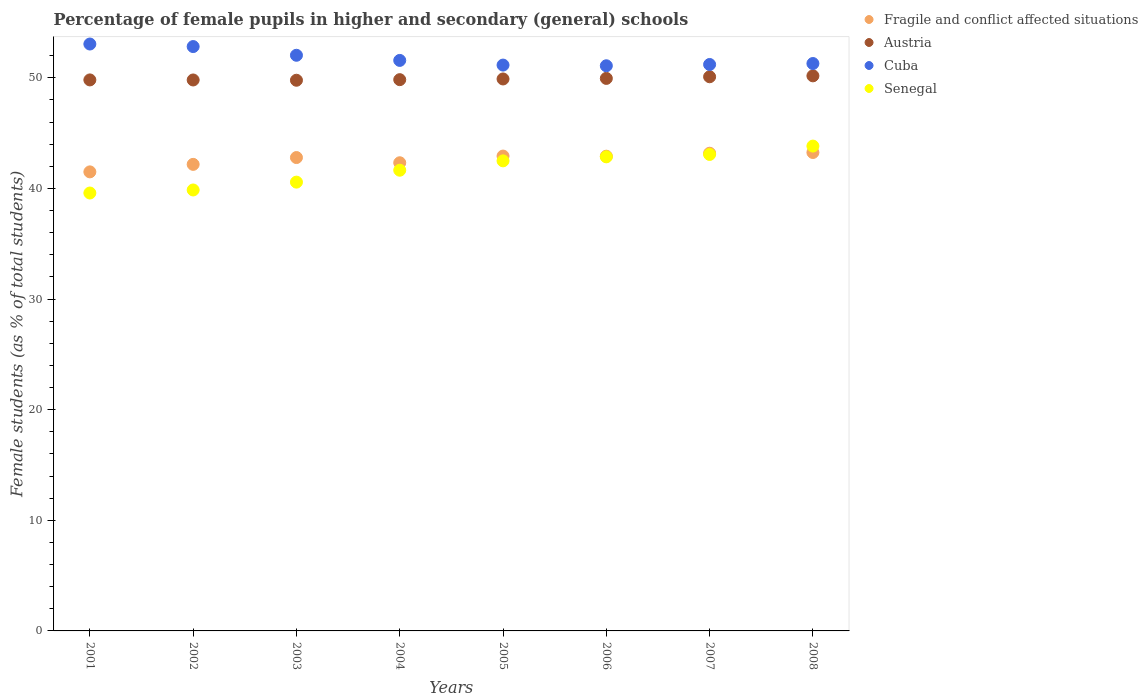How many different coloured dotlines are there?
Ensure brevity in your answer.  4. What is the percentage of female pupils in higher and secondary schools in Cuba in 2007?
Ensure brevity in your answer.  51.2. Across all years, what is the maximum percentage of female pupils in higher and secondary schools in Austria?
Offer a terse response. 50.17. Across all years, what is the minimum percentage of female pupils in higher and secondary schools in Cuba?
Make the answer very short. 51.08. In which year was the percentage of female pupils in higher and secondary schools in Cuba maximum?
Offer a terse response. 2001. What is the total percentage of female pupils in higher and secondary schools in Cuba in the graph?
Make the answer very short. 414.18. What is the difference between the percentage of female pupils in higher and secondary schools in Fragile and conflict affected situations in 2001 and that in 2008?
Your answer should be very brief. -1.75. What is the difference between the percentage of female pupils in higher and secondary schools in Austria in 2002 and the percentage of female pupils in higher and secondary schools in Fragile and conflict affected situations in 2005?
Keep it short and to the point. 6.88. What is the average percentage of female pupils in higher and secondary schools in Austria per year?
Make the answer very short. 49.91. In the year 2004, what is the difference between the percentage of female pupils in higher and secondary schools in Fragile and conflict affected situations and percentage of female pupils in higher and secondary schools in Senegal?
Give a very brief answer. 0.67. What is the ratio of the percentage of female pupils in higher and secondary schools in Cuba in 2002 to that in 2005?
Make the answer very short. 1.03. Is the percentage of female pupils in higher and secondary schools in Austria in 2002 less than that in 2007?
Keep it short and to the point. Yes. What is the difference between the highest and the second highest percentage of female pupils in higher and secondary schools in Fragile and conflict affected situations?
Make the answer very short. 0.07. What is the difference between the highest and the lowest percentage of female pupils in higher and secondary schools in Cuba?
Ensure brevity in your answer.  1.97. Is it the case that in every year, the sum of the percentage of female pupils in higher and secondary schools in Cuba and percentage of female pupils in higher and secondary schools in Fragile and conflict affected situations  is greater than the sum of percentage of female pupils in higher and secondary schools in Senegal and percentage of female pupils in higher and secondary schools in Austria?
Offer a terse response. Yes. Is it the case that in every year, the sum of the percentage of female pupils in higher and secondary schools in Austria and percentage of female pupils in higher and secondary schools in Cuba  is greater than the percentage of female pupils in higher and secondary schools in Fragile and conflict affected situations?
Your answer should be compact. Yes. Does the percentage of female pupils in higher and secondary schools in Austria monotonically increase over the years?
Your answer should be compact. No. Is the percentage of female pupils in higher and secondary schools in Cuba strictly greater than the percentage of female pupils in higher and secondary schools in Austria over the years?
Offer a very short reply. Yes. Is the percentage of female pupils in higher and secondary schools in Fragile and conflict affected situations strictly less than the percentage of female pupils in higher and secondary schools in Senegal over the years?
Offer a very short reply. No. Are the values on the major ticks of Y-axis written in scientific E-notation?
Make the answer very short. No. Does the graph contain any zero values?
Give a very brief answer. No. Does the graph contain grids?
Ensure brevity in your answer.  No. How many legend labels are there?
Keep it short and to the point. 4. What is the title of the graph?
Keep it short and to the point. Percentage of female pupils in higher and secondary (general) schools. Does "Canada" appear as one of the legend labels in the graph?
Your answer should be very brief. No. What is the label or title of the Y-axis?
Provide a succinct answer. Female students (as % of total students). What is the Female students (as % of total students) in Fragile and conflict affected situations in 2001?
Give a very brief answer. 41.49. What is the Female students (as % of total students) of Austria in 2001?
Offer a very short reply. 49.8. What is the Female students (as % of total students) of Cuba in 2001?
Keep it short and to the point. 53.05. What is the Female students (as % of total students) of Senegal in 2001?
Your answer should be compact. 39.58. What is the Female students (as % of total students) of Fragile and conflict affected situations in 2002?
Make the answer very short. 42.17. What is the Female students (as % of total students) of Austria in 2002?
Ensure brevity in your answer.  49.8. What is the Female students (as % of total students) of Cuba in 2002?
Your response must be concise. 52.82. What is the Female students (as % of total students) in Senegal in 2002?
Give a very brief answer. 39.86. What is the Female students (as % of total students) of Fragile and conflict affected situations in 2003?
Offer a very short reply. 42.79. What is the Female students (as % of total students) in Austria in 2003?
Your answer should be very brief. 49.77. What is the Female students (as % of total students) in Cuba in 2003?
Give a very brief answer. 52.03. What is the Female students (as % of total students) of Senegal in 2003?
Offer a very short reply. 40.57. What is the Female students (as % of total students) in Fragile and conflict affected situations in 2004?
Offer a very short reply. 42.32. What is the Female students (as % of total students) in Austria in 2004?
Offer a terse response. 49.83. What is the Female students (as % of total students) in Cuba in 2004?
Your response must be concise. 51.57. What is the Female students (as % of total students) in Senegal in 2004?
Your answer should be very brief. 41.64. What is the Female students (as % of total students) in Fragile and conflict affected situations in 2005?
Offer a terse response. 42.92. What is the Female students (as % of total students) of Austria in 2005?
Offer a terse response. 49.89. What is the Female students (as % of total students) in Cuba in 2005?
Provide a succinct answer. 51.14. What is the Female students (as % of total students) in Senegal in 2005?
Your answer should be very brief. 42.49. What is the Female students (as % of total students) in Fragile and conflict affected situations in 2006?
Make the answer very short. 42.91. What is the Female students (as % of total students) in Austria in 2006?
Provide a succinct answer. 49.94. What is the Female students (as % of total students) of Cuba in 2006?
Offer a terse response. 51.08. What is the Female students (as % of total students) of Senegal in 2006?
Provide a short and direct response. 42.85. What is the Female students (as % of total students) of Fragile and conflict affected situations in 2007?
Your response must be concise. 43.18. What is the Female students (as % of total students) of Austria in 2007?
Your response must be concise. 50.09. What is the Female students (as % of total students) of Cuba in 2007?
Offer a very short reply. 51.2. What is the Female students (as % of total students) of Senegal in 2007?
Provide a succinct answer. 43.07. What is the Female students (as % of total students) in Fragile and conflict affected situations in 2008?
Offer a very short reply. 43.24. What is the Female students (as % of total students) in Austria in 2008?
Your answer should be compact. 50.17. What is the Female students (as % of total students) of Cuba in 2008?
Provide a succinct answer. 51.29. What is the Female students (as % of total students) in Senegal in 2008?
Give a very brief answer. 43.82. Across all years, what is the maximum Female students (as % of total students) in Fragile and conflict affected situations?
Your response must be concise. 43.24. Across all years, what is the maximum Female students (as % of total students) of Austria?
Your response must be concise. 50.17. Across all years, what is the maximum Female students (as % of total students) of Cuba?
Your answer should be compact. 53.05. Across all years, what is the maximum Female students (as % of total students) in Senegal?
Your answer should be very brief. 43.82. Across all years, what is the minimum Female students (as % of total students) in Fragile and conflict affected situations?
Your answer should be very brief. 41.49. Across all years, what is the minimum Female students (as % of total students) of Austria?
Provide a short and direct response. 49.77. Across all years, what is the minimum Female students (as % of total students) of Cuba?
Make the answer very short. 51.08. Across all years, what is the minimum Female students (as % of total students) in Senegal?
Provide a short and direct response. 39.58. What is the total Female students (as % of total students) in Fragile and conflict affected situations in the graph?
Make the answer very short. 341.02. What is the total Female students (as % of total students) in Austria in the graph?
Provide a short and direct response. 399.3. What is the total Female students (as % of total students) in Cuba in the graph?
Provide a succinct answer. 414.18. What is the total Female students (as % of total students) of Senegal in the graph?
Your response must be concise. 333.88. What is the difference between the Female students (as % of total students) in Fragile and conflict affected situations in 2001 and that in 2002?
Provide a succinct answer. -0.68. What is the difference between the Female students (as % of total students) of Austria in 2001 and that in 2002?
Offer a terse response. 0.01. What is the difference between the Female students (as % of total students) of Cuba in 2001 and that in 2002?
Provide a short and direct response. 0.23. What is the difference between the Female students (as % of total students) in Senegal in 2001 and that in 2002?
Ensure brevity in your answer.  -0.28. What is the difference between the Female students (as % of total students) of Fragile and conflict affected situations in 2001 and that in 2003?
Ensure brevity in your answer.  -1.29. What is the difference between the Female students (as % of total students) of Cuba in 2001 and that in 2003?
Offer a terse response. 1.02. What is the difference between the Female students (as % of total students) in Senegal in 2001 and that in 2003?
Your answer should be compact. -0.98. What is the difference between the Female students (as % of total students) of Fragile and conflict affected situations in 2001 and that in 2004?
Offer a very short reply. -0.82. What is the difference between the Female students (as % of total students) in Austria in 2001 and that in 2004?
Give a very brief answer. -0.02. What is the difference between the Female students (as % of total students) of Cuba in 2001 and that in 2004?
Make the answer very short. 1.48. What is the difference between the Female students (as % of total students) of Senegal in 2001 and that in 2004?
Your answer should be very brief. -2.06. What is the difference between the Female students (as % of total students) in Fragile and conflict affected situations in 2001 and that in 2005?
Provide a succinct answer. -1.43. What is the difference between the Female students (as % of total students) in Austria in 2001 and that in 2005?
Give a very brief answer. -0.09. What is the difference between the Female students (as % of total students) of Cuba in 2001 and that in 2005?
Your answer should be compact. 1.9. What is the difference between the Female students (as % of total students) in Senegal in 2001 and that in 2005?
Your answer should be compact. -2.91. What is the difference between the Female students (as % of total students) of Fragile and conflict affected situations in 2001 and that in 2006?
Your answer should be compact. -1.42. What is the difference between the Female students (as % of total students) in Austria in 2001 and that in 2006?
Your answer should be compact. -0.14. What is the difference between the Female students (as % of total students) in Cuba in 2001 and that in 2006?
Offer a very short reply. 1.97. What is the difference between the Female students (as % of total students) in Senegal in 2001 and that in 2006?
Ensure brevity in your answer.  -3.27. What is the difference between the Female students (as % of total students) in Fragile and conflict affected situations in 2001 and that in 2007?
Offer a terse response. -1.69. What is the difference between the Female students (as % of total students) of Austria in 2001 and that in 2007?
Offer a very short reply. -0.28. What is the difference between the Female students (as % of total students) in Cuba in 2001 and that in 2007?
Your answer should be very brief. 1.85. What is the difference between the Female students (as % of total students) in Senegal in 2001 and that in 2007?
Make the answer very short. -3.49. What is the difference between the Female students (as % of total students) of Fragile and conflict affected situations in 2001 and that in 2008?
Offer a very short reply. -1.75. What is the difference between the Female students (as % of total students) of Austria in 2001 and that in 2008?
Keep it short and to the point. -0.37. What is the difference between the Female students (as % of total students) in Cuba in 2001 and that in 2008?
Make the answer very short. 1.76. What is the difference between the Female students (as % of total students) in Senegal in 2001 and that in 2008?
Your response must be concise. -4.24. What is the difference between the Female students (as % of total students) of Fragile and conflict affected situations in 2002 and that in 2003?
Give a very brief answer. -0.62. What is the difference between the Female students (as % of total students) in Austria in 2002 and that in 2003?
Offer a very short reply. 0.03. What is the difference between the Female students (as % of total students) of Cuba in 2002 and that in 2003?
Offer a terse response. 0.79. What is the difference between the Female students (as % of total students) of Senegal in 2002 and that in 2003?
Keep it short and to the point. -0.71. What is the difference between the Female students (as % of total students) in Fragile and conflict affected situations in 2002 and that in 2004?
Provide a succinct answer. -0.15. What is the difference between the Female students (as % of total students) of Austria in 2002 and that in 2004?
Offer a very short reply. -0.03. What is the difference between the Female students (as % of total students) in Cuba in 2002 and that in 2004?
Provide a succinct answer. 1.25. What is the difference between the Female students (as % of total students) of Senegal in 2002 and that in 2004?
Ensure brevity in your answer.  -1.79. What is the difference between the Female students (as % of total students) in Fragile and conflict affected situations in 2002 and that in 2005?
Ensure brevity in your answer.  -0.75. What is the difference between the Female students (as % of total students) of Austria in 2002 and that in 2005?
Give a very brief answer. -0.09. What is the difference between the Female students (as % of total students) of Cuba in 2002 and that in 2005?
Keep it short and to the point. 1.67. What is the difference between the Female students (as % of total students) of Senegal in 2002 and that in 2005?
Your answer should be very brief. -2.63. What is the difference between the Female students (as % of total students) in Fragile and conflict affected situations in 2002 and that in 2006?
Offer a very short reply. -0.74. What is the difference between the Female students (as % of total students) of Austria in 2002 and that in 2006?
Provide a succinct answer. -0.14. What is the difference between the Female students (as % of total students) of Cuba in 2002 and that in 2006?
Offer a terse response. 1.74. What is the difference between the Female students (as % of total students) in Senegal in 2002 and that in 2006?
Keep it short and to the point. -2.99. What is the difference between the Female students (as % of total students) in Fragile and conflict affected situations in 2002 and that in 2007?
Offer a very short reply. -1.01. What is the difference between the Female students (as % of total students) in Austria in 2002 and that in 2007?
Offer a terse response. -0.29. What is the difference between the Female students (as % of total students) in Cuba in 2002 and that in 2007?
Provide a short and direct response. 1.62. What is the difference between the Female students (as % of total students) of Senegal in 2002 and that in 2007?
Your answer should be very brief. -3.21. What is the difference between the Female students (as % of total students) in Fragile and conflict affected situations in 2002 and that in 2008?
Ensure brevity in your answer.  -1.07. What is the difference between the Female students (as % of total students) in Austria in 2002 and that in 2008?
Give a very brief answer. -0.37. What is the difference between the Female students (as % of total students) of Cuba in 2002 and that in 2008?
Your answer should be very brief. 1.53. What is the difference between the Female students (as % of total students) in Senegal in 2002 and that in 2008?
Your answer should be compact. -3.97. What is the difference between the Female students (as % of total students) in Fragile and conflict affected situations in 2003 and that in 2004?
Your answer should be very brief. 0.47. What is the difference between the Female students (as % of total students) of Austria in 2003 and that in 2004?
Ensure brevity in your answer.  -0.05. What is the difference between the Female students (as % of total students) in Cuba in 2003 and that in 2004?
Ensure brevity in your answer.  0.46. What is the difference between the Female students (as % of total students) of Senegal in 2003 and that in 2004?
Provide a short and direct response. -1.08. What is the difference between the Female students (as % of total students) in Fragile and conflict affected situations in 2003 and that in 2005?
Offer a terse response. -0.13. What is the difference between the Female students (as % of total students) in Austria in 2003 and that in 2005?
Offer a very short reply. -0.12. What is the difference between the Female students (as % of total students) in Cuba in 2003 and that in 2005?
Keep it short and to the point. 0.89. What is the difference between the Female students (as % of total students) in Senegal in 2003 and that in 2005?
Provide a succinct answer. -1.92. What is the difference between the Female students (as % of total students) of Fragile and conflict affected situations in 2003 and that in 2006?
Keep it short and to the point. -0.12. What is the difference between the Female students (as % of total students) in Cuba in 2003 and that in 2006?
Ensure brevity in your answer.  0.95. What is the difference between the Female students (as % of total students) in Senegal in 2003 and that in 2006?
Provide a succinct answer. -2.29. What is the difference between the Female students (as % of total students) in Fragile and conflict affected situations in 2003 and that in 2007?
Your response must be concise. -0.39. What is the difference between the Female students (as % of total students) in Austria in 2003 and that in 2007?
Make the answer very short. -0.31. What is the difference between the Female students (as % of total students) of Cuba in 2003 and that in 2007?
Ensure brevity in your answer.  0.83. What is the difference between the Female students (as % of total students) in Senegal in 2003 and that in 2007?
Offer a terse response. -2.5. What is the difference between the Female students (as % of total students) in Fragile and conflict affected situations in 2003 and that in 2008?
Provide a short and direct response. -0.46. What is the difference between the Female students (as % of total students) in Austria in 2003 and that in 2008?
Provide a short and direct response. -0.4. What is the difference between the Female students (as % of total students) in Cuba in 2003 and that in 2008?
Your response must be concise. 0.75. What is the difference between the Female students (as % of total students) in Senegal in 2003 and that in 2008?
Your response must be concise. -3.26. What is the difference between the Female students (as % of total students) in Fragile and conflict affected situations in 2004 and that in 2005?
Give a very brief answer. -0.6. What is the difference between the Female students (as % of total students) in Austria in 2004 and that in 2005?
Your response must be concise. -0.06. What is the difference between the Female students (as % of total students) in Cuba in 2004 and that in 2005?
Your answer should be compact. 0.42. What is the difference between the Female students (as % of total students) in Senegal in 2004 and that in 2005?
Your response must be concise. -0.85. What is the difference between the Female students (as % of total students) of Fragile and conflict affected situations in 2004 and that in 2006?
Provide a short and direct response. -0.59. What is the difference between the Female students (as % of total students) in Austria in 2004 and that in 2006?
Keep it short and to the point. -0.11. What is the difference between the Female students (as % of total students) of Cuba in 2004 and that in 2006?
Provide a succinct answer. 0.48. What is the difference between the Female students (as % of total students) of Senegal in 2004 and that in 2006?
Keep it short and to the point. -1.21. What is the difference between the Female students (as % of total students) of Fragile and conflict affected situations in 2004 and that in 2007?
Make the answer very short. -0.86. What is the difference between the Female students (as % of total students) of Austria in 2004 and that in 2007?
Offer a very short reply. -0.26. What is the difference between the Female students (as % of total students) in Cuba in 2004 and that in 2007?
Your answer should be very brief. 0.37. What is the difference between the Female students (as % of total students) in Senegal in 2004 and that in 2007?
Your response must be concise. -1.42. What is the difference between the Female students (as % of total students) of Fragile and conflict affected situations in 2004 and that in 2008?
Provide a short and direct response. -0.93. What is the difference between the Female students (as % of total students) of Austria in 2004 and that in 2008?
Keep it short and to the point. -0.34. What is the difference between the Female students (as % of total students) of Cuba in 2004 and that in 2008?
Your answer should be very brief. 0.28. What is the difference between the Female students (as % of total students) in Senegal in 2004 and that in 2008?
Your response must be concise. -2.18. What is the difference between the Female students (as % of total students) in Fragile and conflict affected situations in 2005 and that in 2006?
Your answer should be very brief. 0.01. What is the difference between the Female students (as % of total students) in Austria in 2005 and that in 2006?
Give a very brief answer. -0.05. What is the difference between the Female students (as % of total students) in Cuba in 2005 and that in 2006?
Give a very brief answer. 0.06. What is the difference between the Female students (as % of total students) of Senegal in 2005 and that in 2006?
Ensure brevity in your answer.  -0.36. What is the difference between the Female students (as % of total students) in Fragile and conflict affected situations in 2005 and that in 2007?
Give a very brief answer. -0.26. What is the difference between the Female students (as % of total students) in Austria in 2005 and that in 2007?
Provide a short and direct response. -0.2. What is the difference between the Female students (as % of total students) of Cuba in 2005 and that in 2007?
Your answer should be compact. -0.05. What is the difference between the Female students (as % of total students) in Senegal in 2005 and that in 2007?
Provide a short and direct response. -0.58. What is the difference between the Female students (as % of total students) in Fragile and conflict affected situations in 2005 and that in 2008?
Offer a very short reply. -0.32. What is the difference between the Female students (as % of total students) of Austria in 2005 and that in 2008?
Give a very brief answer. -0.28. What is the difference between the Female students (as % of total students) in Cuba in 2005 and that in 2008?
Keep it short and to the point. -0.14. What is the difference between the Female students (as % of total students) in Senegal in 2005 and that in 2008?
Keep it short and to the point. -1.34. What is the difference between the Female students (as % of total students) of Fragile and conflict affected situations in 2006 and that in 2007?
Ensure brevity in your answer.  -0.27. What is the difference between the Female students (as % of total students) in Austria in 2006 and that in 2007?
Ensure brevity in your answer.  -0.15. What is the difference between the Female students (as % of total students) in Cuba in 2006 and that in 2007?
Make the answer very short. -0.12. What is the difference between the Female students (as % of total students) in Senegal in 2006 and that in 2007?
Your answer should be compact. -0.22. What is the difference between the Female students (as % of total students) in Fragile and conflict affected situations in 2006 and that in 2008?
Provide a short and direct response. -0.33. What is the difference between the Female students (as % of total students) of Austria in 2006 and that in 2008?
Make the answer very short. -0.23. What is the difference between the Female students (as % of total students) of Cuba in 2006 and that in 2008?
Ensure brevity in your answer.  -0.2. What is the difference between the Female students (as % of total students) of Senegal in 2006 and that in 2008?
Provide a succinct answer. -0.97. What is the difference between the Female students (as % of total students) in Fragile and conflict affected situations in 2007 and that in 2008?
Keep it short and to the point. -0.07. What is the difference between the Female students (as % of total students) of Austria in 2007 and that in 2008?
Keep it short and to the point. -0.08. What is the difference between the Female students (as % of total students) in Cuba in 2007 and that in 2008?
Offer a terse response. -0.09. What is the difference between the Female students (as % of total students) in Senegal in 2007 and that in 2008?
Your answer should be compact. -0.76. What is the difference between the Female students (as % of total students) in Fragile and conflict affected situations in 2001 and the Female students (as % of total students) in Austria in 2002?
Give a very brief answer. -8.31. What is the difference between the Female students (as % of total students) of Fragile and conflict affected situations in 2001 and the Female students (as % of total students) of Cuba in 2002?
Your answer should be very brief. -11.33. What is the difference between the Female students (as % of total students) of Fragile and conflict affected situations in 2001 and the Female students (as % of total students) of Senegal in 2002?
Provide a succinct answer. 1.64. What is the difference between the Female students (as % of total students) in Austria in 2001 and the Female students (as % of total students) in Cuba in 2002?
Your answer should be compact. -3.01. What is the difference between the Female students (as % of total students) in Austria in 2001 and the Female students (as % of total students) in Senegal in 2002?
Your response must be concise. 9.95. What is the difference between the Female students (as % of total students) of Cuba in 2001 and the Female students (as % of total students) of Senegal in 2002?
Give a very brief answer. 13.19. What is the difference between the Female students (as % of total students) in Fragile and conflict affected situations in 2001 and the Female students (as % of total students) in Austria in 2003?
Your response must be concise. -8.28. What is the difference between the Female students (as % of total students) of Fragile and conflict affected situations in 2001 and the Female students (as % of total students) of Cuba in 2003?
Keep it short and to the point. -10.54. What is the difference between the Female students (as % of total students) in Fragile and conflict affected situations in 2001 and the Female students (as % of total students) in Senegal in 2003?
Keep it short and to the point. 0.93. What is the difference between the Female students (as % of total students) in Austria in 2001 and the Female students (as % of total students) in Cuba in 2003?
Make the answer very short. -2.23. What is the difference between the Female students (as % of total students) of Austria in 2001 and the Female students (as % of total students) of Senegal in 2003?
Keep it short and to the point. 9.24. What is the difference between the Female students (as % of total students) in Cuba in 2001 and the Female students (as % of total students) in Senegal in 2003?
Provide a short and direct response. 12.48. What is the difference between the Female students (as % of total students) of Fragile and conflict affected situations in 2001 and the Female students (as % of total students) of Austria in 2004?
Make the answer very short. -8.33. What is the difference between the Female students (as % of total students) of Fragile and conflict affected situations in 2001 and the Female students (as % of total students) of Cuba in 2004?
Keep it short and to the point. -10.08. What is the difference between the Female students (as % of total students) of Fragile and conflict affected situations in 2001 and the Female students (as % of total students) of Senegal in 2004?
Give a very brief answer. -0.15. What is the difference between the Female students (as % of total students) in Austria in 2001 and the Female students (as % of total students) in Cuba in 2004?
Offer a very short reply. -1.76. What is the difference between the Female students (as % of total students) in Austria in 2001 and the Female students (as % of total students) in Senegal in 2004?
Make the answer very short. 8.16. What is the difference between the Female students (as % of total students) in Cuba in 2001 and the Female students (as % of total students) in Senegal in 2004?
Your answer should be compact. 11.41. What is the difference between the Female students (as % of total students) of Fragile and conflict affected situations in 2001 and the Female students (as % of total students) of Austria in 2005?
Provide a succinct answer. -8.4. What is the difference between the Female students (as % of total students) of Fragile and conflict affected situations in 2001 and the Female students (as % of total students) of Cuba in 2005?
Provide a succinct answer. -9.65. What is the difference between the Female students (as % of total students) of Fragile and conflict affected situations in 2001 and the Female students (as % of total students) of Senegal in 2005?
Keep it short and to the point. -1. What is the difference between the Female students (as % of total students) in Austria in 2001 and the Female students (as % of total students) in Cuba in 2005?
Your answer should be compact. -1.34. What is the difference between the Female students (as % of total students) in Austria in 2001 and the Female students (as % of total students) in Senegal in 2005?
Your response must be concise. 7.32. What is the difference between the Female students (as % of total students) of Cuba in 2001 and the Female students (as % of total students) of Senegal in 2005?
Provide a short and direct response. 10.56. What is the difference between the Female students (as % of total students) in Fragile and conflict affected situations in 2001 and the Female students (as % of total students) in Austria in 2006?
Your response must be concise. -8.45. What is the difference between the Female students (as % of total students) in Fragile and conflict affected situations in 2001 and the Female students (as % of total students) in Cuba in 2006?
Give a very brief answer. -9.59. What is the difference between the Female students (as % of total students) of Fragile and conflict affected situations in 2001 and the Female students (as % of total students) of Senegal in 2006?
Your answer should be very brief. -1.36. What is the difference between the Female students (as % of total students) of Austria in 2001 and the Female students (as % of total students) of Cuba in 2006?
Provide a short and direct response. -1.28. What is the difference between the Female students (as % of total students) of Austria in 2001 and the Female students (as % of total students) of Senegal in 2006?
Provide a short and direct response. 6.95. What is the difference between the Female students (as % of total students) in Cuba in 2001 and the Female students (as % of total students) in Senegal in 2006?
Give a very brief answer. 10.2. What is the difference between the Female students (as % of total students) of Fragile and conflict affected situations in 2001 and the Female students (as % of total students) of Austria in 2007?
Provide a short and direct response. -8.6. What is the difference between the Female students (as % of total students) in Fragile and conflict affected situations in 2001 and the Female students (as % of total students) in Cuba in 2007?
Provide a short and direct response. -9.71. What is the difference between the Female students (as % of total students) of Fragile and conflict affected situations in 2001 and the Female students (as % of total students) of Senegal in 2007?
Provide a succinct answer. -1.57. What is the difference between the Female students (as % of total students) of Austria in 2001 and the Female students (as % of total students) of Cuba in 2007?
Provide a succinct answer. -1.39. What is the difference between the Female students (as % of total students) of Austria in 2001 and the Female students (as % of total students) of Senegal in 2007?
Your answer should be very brief. 6.74. What is the difference between the Female students (as % of total students) of Cuba in 2001 and the Female students (as % of total students) of Senegal in 2007?
Keep it short and to the point. 9.98. What is the difference between the Female students (as % of total students) of Fragile and conflict affected situations in 2001 and the Female students (as % of total students) of Austria in 2008?
Offer a very short reply. -8.68. What is the difference between the Female students (as % of total students) of Fragile and conflict affected situations in 2001 and the Female students (as % of total students) of Cuba in 2008?
Offer a very short reply. -9.79. What is the difference between the Female students (as % of total students) of Fragile and conflict affected situations in 2001 and the Female students (as % of total students) of Senegal in 2008?
Your response must be concise. -2.33. What is the difference between the Female students (as % of total students) in Austria in 2001 and the Female students (as % of total students) in Cuba in 2008?
Offer a terse response. -1.48. What is the difference between the Female students (as % of total students) in Austria in 2001 and the Female students (as % of total students) in Senegal in 2008?
Ensure brevity in your answer.  5.98. What is the difference between the Female students (as % of total students) of Cuba in 2001 and the Female students (as % of total students) of Senegal in 2008?
Ensure brevity in your answer.  9.22. What is the difference between the Female students (as % of total students) in Fragile and conflict affected situations in 2002 and the Female students (as % of total students) in Austria in 2003?
Make the answer very short. -7.6. What is the difference between the Female students (as % of total students) in Fragile and conflict affected situations in 2002 and the Female students (as % of total students) in Cuba in 2003?
Give a very brief answer. -9.86. What is the difference between the Female students (as % of total students) in Fragile and conflict affected situations in 2002 and the Female students (as % of total students) in Senegal in 2003?
Give a very brief answer. 1.6. What is the difference between the Female students (as % of total students) in Austria in 2002 and the Female students (as % of total students) in Cuba in 2003?
Provide a succinct answer. -2.23. What is the difference between the Female students (as % of total students) in Austria in 2002 and the Female students (as % of total students) in Senegal in 2003?
Keep it short and to the point. 9.23. What is the difference between the Female students (as % of total students) in Cuba in 2002 and the Female students (as % of total students) in Senegal in 2003?
Your answer should be very brief. 12.25. What is the difference between the Female students (as % of total students) of Fragile and conflict affected situations in 2002 and the Female students (as % of total students) of Austria in 2004?
Make the answer very short. -7.66. What is the difference between the Female students (as % of total students) of Fragile and conflict affected situations in 2002 and the Female students (as % of total students) of Cuba in 2004?
Give a very brief answer. -9.4. What is the difference between the Female students (as % of total students) in Fragile and conflict affected situations in 2002 and the Female students (as % of total students) in Senegal in 2004?
Ensure brevity in your answer.  0.53. What is the difference between the Female students (as % of total students) of Austria in 2002 and the Female students (as % of total students) of Cuba in 2004?
Your answer should be compact. -1.77. What is the difference between the Female students (as % of total students) in Austria in 2002 and the Female students (as % of total students) in Senegal in 2004?
Give a very brief answer. 8.16. What is the difference between the Female students (as % of total students) of Cuba in 2002 and the Female students (as % of total students) of Senegal in 2004?
Provide a succinct answer. 11.18. What is the difference between the Female students (as % of total students) in Fragile and conflict affected situations in 2002 and the Female students (as % of total students) in Austria in 2005?
Your answer should be very brief. -7.72. What is the difference between the Female students (as % of total students) in Fragile and conflict affected situations in 2002 and the Female students (as % of total students) in Cuba in 2005?
Provide a short and direct response. -8.97. What is the difference between the Female students (as % of total students) in Fragile and conflict affected situations in 2002 and the Female students (as % of total students) in Senegal in 2005?
Your response must be concise. -0.32. What is the difference between the Female students (as % of total students) of Austria in 2002 and the Female students (as % of total students) of Cuba in 2005?
Provide a short and direct response. -1.35. What is the difference between the Female students (as % of total students) of Austria in 2002 and the Female students (as % of total students) of Senegal in 2005?
Give a very brief answer. 7.31. What is the difference between the Female students (as % of total students) in Cuba in 2002 and the Female students (as % of total students) in Senegal in 2005?
Your answer should be very brief. 10.33. What is the difference between the Female students (as % of total students) in Fragile and conflict affected situations in 2002 and the Female students (as % of total students) in Austria in 2006?
Provide a succinct answer. -7.77. What is the difference between the Female students (as % of total students) in Fragile and conflict affected situations in 2002 and the Female students (as % of total students) in Cuba in 2006?
Make the answer very short. -8.91. What is the difference between the Female students (as % of total students) of Fragile and conflict affected situations in 2002 and the Female students (as % of total students) of Senegal in 2006?
Keep it short and to the point. -0.68. What is the difference between the Female students (as % of total students) of Austria in 2002 and the Female students (as % of total students) of Cuba in 2006?
Provide a short and direct response. -1.28. What is the difference between the Female students (as % of total students) in Austria in 2002 and the Female students (as % of total students) in Senegal in 2006?
Offer a very short reply. 6.95. What is the difference between the Female students (as % of total students) in Cuba in 2002 and the Female students (as % of total students) in Senegal in 2006?
Ensure brevity in your answer.  9.97. What is the difference between the Female students (as % of total students) in Fragile and conflict affected situations in 2002 and the Female students (as % of total students) in Austria in 2007?
Provide a succinct answer. -7.92. What is the difference between the Female students (as % of total students) in Fragile and conflict affected situations in 2002 and the Female students (as % of total students) in Cuba in 2007?
Your answer should be compact. -9.03. What is the difference between the Female students (as % of total students) of Fragile and conflict affected situations in 2002 and the Female students (as % of total students) of Senegal in 2007?
Keep it short and to the point. -0.9. What is the difference between the Female students (as % of total students) of Austria in 2002 and the Female students (as % of total students) of Cuba in 2007?
Give a very brief answer. -1.4. What is the difference between the Female students (as % of total students) of Austria in 2002 and the Female students (as % of total students) of Senegal in 2007?
Ensure brevity in your answer.  6.73. What is the difference between the Female students (as % of total students) in Cuba in 2002 and the Female students (as % of total students) in Senegal in 2007?
Offer a terse response. 9.75. What is the difference between the Female students (as % of total students) of Fragile and conflict affected situations in 2002 and the Female students (as % of total students) of Austria in 2008?
Ensure brevity in your answer.  -8. What is the difference between the Female students (as % of total students) of Fragile and conflict affected situations in 2002 and the Female students (as % of total students) of Cuba in 2008?
Provide a short and direct response. -9.12. What is the difference between the Female students (as % of total students) of Fragile and conflict affected situations in 2002 and the Female students (as % of total students) of Senegal in 2008?
Offer a very short reply. -1.65. What is the difference between the Female students (as % of total students) in Austria in 2002 and the Female students (as % of total students) in Cuba in 2008?
Provide a short and direct response. -1.49. What is the difference between the Female students (as % of total students) in Austria in 2002 and the Female students (as % of total students) in Senegal in 2008?
Your answer should be very brief. 5.98. What is the difference between the Female students (as % of total students) in Cuba in 2002 and the Female students (as % of total students) in Senegal in 2008?
Make the answer very short. 8.99. What is the difference between the Female students (as % of total students) in Fragile and conflict affected situations in 2003 and the Female students (as % of total students) in Austria in 2004?
Provide a short and direct response. -7.04. What is the difference between the Female students (as % of total students) of Fragile and conflict affected situations in 2003 and the Female students (as % of total students) of Cuba in 2004?
Provide a short and direct response. -8.78. What is the difference between the Female students (as % of total students) of Fragile and conflict affected situations in 2003 and the Female students (as % of total students) of Senegal in 2004?
Make the answer very short. 1.14. What is the difference between the Female students (as % of total students) of Austria in 2003 and the Female students (as % of total students) of Cuba in 2004?
Offer a very short reply. -1.79. What is the difference between the Female students (as % of total students) of Austria in 2003 and the Female students (as % of total students) of Senegal in 2004?
Offer a very short reply. 8.13. What is the difference between the Female students (as % of total students) in Cuba in 2003 and the Female students (as % of total students) in Senegal in 2004?
Your answer should be compact. 10.39. What is the difference between the Female students (as % of total students) of Fragile and conflict affected situations in 2003 and the Female students (as % of total students) of Austria in 2005?
Your answer should be compact. -7.1. What is the difference between the Female students (as % of total students) of Fragile and conflict affected situations in 2003 and the Female students (as % of total students) of Cuba in 2005?
Offer a very short reply. -8.36. What is the difference between the Female students (as % of total students) in Fragile and conflict affected situations in 2003 and the Female students (as % of total students) in Senegal in 2005?
Make the answer very short. 0.3. What is the difference between the Female students (as % of total students) in Austria in 2003 and the Female students (as % of total students) in Cuba in 2005?
Keep it short and to the point. -1.37. What is the difference between the Female students (as % of total students) of Austria in 2003 and the Female students (as % of total students) of Senegal in 2005?
Keep it short and to the point. 7.29. What is the difference between the Female students (as % of total students) in Cuba in 2003 and the Female students (as % of total students) in Senegal in 2005?
Your response must be concise. 9.54. What is the difference between the Female students (as % of total students) of Fragile and conflict affected situations in 2003 and the Female students (as % of total students) of Austria in 2006?
Ensure brevity in your answer.  -7.15. What is the difference between the Female students (as % of total students) of Fragile and conflict affected situations in 2003 and the Female students (as % of total students) of Cuba in 2006?
Your response must be concise. -8.3. What is the difference between the Female students (as % of total students) of Fragile and conflict affected situations in 2003 and the Female students (as % of total students) of Senegal in 2006?
Your answer should be compact. -0.06. What is the difference between the Female students (as % of total students) in Austria in 2003 and the Female students (as % of total students) in Cuba in 2006?
Provide a short and direct response. -1.31. What is the difference between the Female students (as % of total students) of Austria in 2003 and the Female students (as % of total students) of Senegal in 2006?
Offer a very short reply. 6.92. What is the difference between the Female students (as % of total students) of Cuba in 2003 and the Female students (as % of total students) of Senegal in 2006?
Keep it short and to the point. 9.18. What is the difference between the Female students (as % of total students) of Fragile and conflict affected situations in 2003 and the Female students (as % of total students) of Austria in 2007?
Your response must be concise. -7.3. What is the difference between the Female students (as % of total students) in Fragile and conflict affected situations in 2003 and the Female students (as % of total students) in Cuba in 2007?
Give a very brief answer. -8.41. What is the difference between the Female students (as % of total students) in Fragile and conflict affected situations in 2003 and the Female students (as % of total students) in Senegal in 2007?
Your answer should be very brief. -0.28. What is the difference between the Female students (as % of total students) in Austria in 2003 and the Female students (as % of total students) in Cuba in 2007?
Provide a succinct answer. -1.42. What is the difference between the Female students (as % of total students) of Austria in 2003 and the Female students (as % of total students) of Senegal in 2007?
Your answer should be very brief. 6.71. What is the difference between the Female students (as % of total students) of Cuba in 2003 and the Female students (as % of total students) of Senegal in 2007?
Your answer should be very brief. 8.96. What is the difference between the Female students (as % of total students) in Fragile and conflict affected situations in 2003 and the Female students (as % of total students) in Austria in 2008?
Offer a terse response. -7.39. What is the difference between the Female students (as % of total students) in Fragile and conflict affected situations in 2003 and the Female students (as % of total students) in Cuba in 2008?
Offer a very short reply. -8.5. What is the difference between the Female students (as % of total students) of Fragile and conflict affected situations in 2003 and the Female students (as % of total students) of Senegal in 2008?
Provide a succinct answer. -1.04. What is the difference between the Female students (as % of total students) of Austria in 2003 and the Female students (as % of total students) of Cuba in 2008?
Keep it short and to the point. -1.51. What is the difference between the Female students (as % of total students) of Austria in 2003 and the Female students (as % of total students) of Senegal in 2008?
Give a very brief answer. 5.95. What is the difference between the Female students (as % of total students) of Cuba in 2003 and the Female students (as % of total students) of Senegal in 2008?
Your answer should be compact. 8.21. What is the difference between the Female students (as % of total students) in Fragile and conflict affected situations in 2004 and the Female students (as % of total students) in Austria in 2005?
Provide a succinct answer. -7.57. What is the difference between the Female students (as % of total students) in Fragile and conflict affected situations in 2004 and the Female students (as % of total students) in Cuba in 2005?
Offer a terse response. -8.83. What is the difference between the Female students (as % of total students) in Fragile and conflict affected situations in 2004 and the Female students (as % of total students) in Senegal in 2005?
Offer a terse response. -0.17. What is the difference between the Female students (as % of total students) in Austria in 2004 and the Female students (as % of total students) in Cuba in 2005?
Provide a short and direct response. -1.32. What is the difference between the Female students (as % of total students) in Austria in 2004 and the Female students (as % of total students) in Senegal in 2005?
Provide a succinct answer. 7.34. What is the difference between the Female students (as % of total students) in Cuba in 2004 and the Female students (as % of total students) in Senegal in 2005?
Your answer should be very brief. 9.08. What is the difference between the Female students (as % of total students) of Fragile and conflict affected situations in 2004 and the Female students (as % of total students) of Austria in 2006?
Offer a terse response. -7.62. What is the difference between the Female students (as % of total students) in Fragile and conflict affected situations in 2004 and the Female students (as % of total students) in Cuba in 2006?
Provide a succinct answer. -8.77. What is the difference between the Female students (as % of total students) of Fragile and conflict affected situations in 2004 and the Female students (as % of total students) of Senegal in 2006?
Your answer should be compact. -0.53. What is the difference between the Female students (as % of total students) in Austria in 2004 and the Female students (as % of total students) in Cuba in 2006?
Your response must be concise. -1.26. What is the difference between the Female students (as % of total students) in Austria in 2004 and the Female students (as % of total students) in Senegal in 2006?
Your response must be concise. 6.98. What is the difference between the Female students (as % of total students) in Cuba in 2004 and the Female students (as % of total students) in Senegal in 2006?
Your response must be concise. 8.72. What is the difference between the Female students (as % of total students) in Fragile and conflict affected situations in 2004 and the Female students (as % of total students) in Austria in 2007?
Provide a succinct answer. -7.77. What is the difference between the Female students (as % of total students) of Fragile and conflict affected situations in 2004 and the Female students (as % of total students) of Cuba in 2007?
Ensure brevity in your answer.  -8.88. What is the difference between the Female students (as % of total students) of Fragile and conflict affected situations in 2004 and the Female students (as % of total students) of Senegal in 2007?
Ensure brevity in your answer.  -0.75. What is the difference between the Female students (as % of total students) in Austria in 2004 and the Female students (as % of total students) in Cuba in 2007?
Make the answer very short. -1.37. What is the difference between the Female students (as % of total students) of Austria in 2004 and the Female students (as % of total students) of Senegal in 2007?
Provide a short and direct response. 6.76. What is the difference between the Female students (as % of total students) of Cuba in 2004 and the Female students (as % of total students) of Senegal in 2007?
Make the answer very short. 8.5. What is the difference between the Female students (as % of total students) of Fragile and conflict affected situations in 2004 and the Female students (as % of total students) of Austria in 2008?
Keep it short and to the point. -7.85. What is the difference between the Female students (as % of total students) in Fragile and conflict affected situations in 2004 and the Female students (as % of total students) in Cuba in 2008?
Make the answer very short. -8.97. What is the difference between the Female students (as % of total students) in Fragile and conflict affected situations in 2004 and the Female students (as % of total students) in Senegal in 2008?
Offer a terse response. -1.51. What is the difference between the Female students (as % of total students) in Austria in 2004 and the Female students (as % of total students) in Cuba in 2008?
Offer a very short reply. -1.46. What is the difference between the Female students (as % of total students) of Austria in 2004 and the Female students (as % of total students) of Senegal in 2008?
Provide a succinct answer. 6. What is the difference between the Female students (as % of total students) in Cuba in 2004 and the Female students (as % of total students) in Senegal in 2008?
Give a very brief answer. 7.74. What is the difference between the Female students (as % of total students) of Fragile and conflict affected situations in 2005 and the Female students (as % of total students) of Austria in 2006?
Keep it short and to the point. -7.02. What is the difference between the Female students (as % of total students) in Fragile and conflict affected situations in 2005 and the Female students (as % of total students) in Cuba in 2006?
Keep it short and to the point. -8.16. What is the difference between the Female students (as % of total students) in Fragile and conflict affected situations in 2005 and the Female students (as % of total students) in Senegal in 2006?
Your response must be concise. 0.07. What is the difference between the Female students (as % of total students) of Austria in 2005 and the Female students (as % of total students) of Cuba in 2006?
Give a very brief answer. -1.19. What is the difference between the Female students (as % of total students) in Austria in 2005 and the Female students (as % of total students) in Senegal in 2006?
Your response must be concise. 7.04. What is the difference between the Female students (as % of total students) of Cuba in 2005 and the Female students (as % of total students) of Senegal in 2006?
Offer a very short reply. 8.29. What is the difference between the Female students (as % of total students) of Fragile and conflict affected situations in 2005 and the Female students (as % of total students) of Austria in 2007?
Keep it short and to the point. -7.17. What is the difference between the Female students (as % of total students) in Fragile and conflict affected situations in 2005 and the Female students (as % of total students) in Cuba in 2007?
Keep it short and to the point. -8.28. What is the difference between the Female students (as % of total students) of Fragile and conflict affected situations in 2005 and the Female students (as % of total students) of Senegal in 2007?
Make the answer very short. -0.15. What is the difference between the Female students (as % of total students) of Austria in 2005 and the Female students (as % of total students) of Cuba in 2007?
Offer a terse response. -1.31. What is the difference between the Female students (as % of total students) of Austria in 2005 and the Female students (as % of total students) of Senegal in 2007?
Ensure brevity in your answer.  6.82. What is the difference between the Female students (as % of total students) of Cuba in 2005 and the Female students (as % of total students) of Senegal in 2007?
Give a very brief answer. 8.08. What is the difference between the Female students (as % of total students) of Fragile and conflict affected situations in 2005 and the Female students (as % of total students) of Austria in 2008?
Provide a succinct answer. -7.25. What is the difference between the Female students (as % of total students) of Fragile and conflict affected situations in 2005 and the Female students (as % of total students) of Cuba in 2008?
Give a very brief answer. -8.36. What is the difference between the Female students (as % of total students) in Fragile and conflict affected situations in 2005 and the Female students (as % of total students) in Senegal in 2008?
Keep it short and to the point. -0.9. What is the difference between the Female students (as % of total students) of Austria in 2005 and the Female students (as % of total students) of Cuba in 2008?
Offer a terse response. -1.4. What is the difference between the Female students (as % of total students) in Austria in 2005 and the Female students (as % of total students) in Senegal in 2008?
Your answer should be compact. 6.07. What is the difference between the Female students (as % of total students) of Cuba in 2005 and the Female students (as % of total students) of Senegal in 2008?
Keep it short and to the point. 7.32. What is the difference between the Female students (as % of total students) of Fragile and conflict affected situations in 2006 and the Female students (as % of total students) of Austria in 2007?
Provide a short and direct response. -7.18. What is the difference between the Female students (as % of total students) in Fragile and conflict affected situations in 2006 and the Female students (as % of total students) in Cuba in 2007?
Your response must be concise. -8.29. What is the difference between the Female students (as % of total students) of Fragile and conflict affected situations in 2006 and the Female students (as % of total students) of Senegal in 2007?
Your response must be concise. -0.16. What is the difference between the Female students (as % of total students) in Austria in 2006 and the Female students (as % of total students) in Cuba in 2007?
Your answer should be compact. -1.26. What is the difference between the Female students (as % of total students) in Austria in 2006 and the Female students (as % of total students) in Senegal in 2007?
Ensure brevity in your answer.  6.87. What is the difference between the Female students (as % of total students) in Cuba in 2006 and the Female students (as % of total students) in Senegal in 2007?
Make the answer very short. 8.02. What is the difference between the Female students (as % of total students) of Fragile and conflict affected situations in 2006 and the Female students (as % of total students) of Austria in 2008?
Keep it short and to the point. -7.26. What is the difference between the Female students (as % of total students) in Fragile and conflict affected situations in 2006 and the Female students (as % of total students) in Cuba in 2008?
Offer a terse response. -8.38. What is the difference between the Female students (as % of total students) in Fragile and conflict affected situations in 2006 and the Female students (as % of total students) in Senegal in 2008?
Keep it short and to the point. -0.91. What is the difference between the Female students (as % of total students) in Austria in 2006 and the Female students (as % of total students) in Cuba in 2008?
Your response must be concise. -1.34. What is the difference between the Female students (as % of total students) of Austria in 2006 and the Female students (as % of total students) of Senegal in 2008?
Offer a terse response. 6.12. What is the difference between the Female students (as % of total students) in Cuba in 2006 and the Female students (as % of total students) in Senegal in 2008?
Offer a very short reply. 7.26. What is the difference between the Female students (as % of total students) of Fragile and conflict affected situations in 2007 and the Female students (as % of total students) of Austria in 2008?
Provide a short and direct response. -6.99. What is the difference between the Female students (as % of total students) of Fragile and conflict affected situations in 2007 and the Female students (as % of total students) of Cuba in 2008?
Your answer should be compact. -8.11. What is the difference between the Female students (as % of total students) in Fragile and conflict affected situations in 2007 and the Female students (as % of total students) in Senegal in 2008?
Your response must be concise. -0.65. What is the difference between the Female students (as % of total students) of Austria in 2007 and the Female students (as % of total students) of Cuba in 2008?
Provide a succinct answer. -1.2. What is the difference between the Female students (as % of total students) in Austria in 2007 and the Female students (as % of total students) in Senegal in 2008?
Offer a terse response. 6.26. What is the difference between the Female students (as % of total students) in Cuba in 2007 and the Female students (as % of total students) in Senegal in 2008?
Provide a succinct answer. 7.38. What is the average Female students (as % of total students) in Fragile and conflict affected situations per year?
Give a very brief answer. 42.63. What is the average Female students (as % of total students) of Austria per year?
Ensure brevity in your answer.  49.91. What is the average Female students (as % of total students) of Cuba per year?
Offer a very short reply. 51.77. What is the average Female students (as % of total students) in Senegal per year?
Your answer should be very brief. 41.73. In the year 2001, what is the difference between the Female students (as % of total students) of Fragile and conflict affected situations and Female students (as % of total students) of Austria?
Provide a short and direct response. -8.31. In the year 2001, what is the difference between the Female students (as % of total students) of Fragile and conflict affected situations and Female students (as % of total students) of Cuba?
Give a very brief answer. -11.56. In the year 2001, what is the difference between the Female students (as % of total students) of Fragile and conflict affected situations and Female students (as % of total students) of Senegal?
Keep it short and to the point. 1.91. In the year 2001, what is the difference between the Female students (as % of total students) of Austria and Female students (as % of total students) of Cuba?
Make the answer very short. -3.24. In the year 2001, what is the difference between the Female students (as % of total students) of Austria and Female students (as % of total students) of Senegal?
Keep it short and to the point. 10.22. In the year 2001, what is the difference between the Female students (as % of total students) in Cuba and Female students (as % of total students) in Senegal?
Your answer should be compact. 13.47. In the year 2002, what is the difference between the Female students (as % of total students) in Fragile and conflict affected situations and Female students (as % of total students) in Austria?
Offer a terse response. -7.63. In the year 2002, what is the difference between the Female students (as % of total students) of Fragile and conflict affected situations and Female students (as % of total students) of Cuba?
Your answer should be compact. -10.65. In the year 2002, what is the difference between the Female students (as % of total students) in Fragile and conflict affected situations and Female students (as % of total students) in Senegal?
Your answer should be very brief. 2.31. In the year 2002, what is the difference between the Female students (as % of total students) in Austria and Female students (as % of total students) in Cuba?
Ensure brevity in your answer.  -3.02. In the year 2002, what is the difference between the Female students (as % of total students) of Austria and Female students (as % of total students) of Senegal?
Your answer should be very brief. 9.94. In the year 2002, what is the difference between the Female students (as % of total students) of Cuba and Female students (as % of total students) of Senegal?
Keep it short and to the point. 12.96. In the year 2003, what is the difference between the Female students (as % of total students) of Fragile and conflict affected situations and Female students (as % of total students) of Austria?
Offer a terse response. -6.99. In the year 2003, what is the difference between the Female students (as % of total students) in Fragile and conflict affected situations and Female students (as % of total students) in Cuba?
Keep it short and to the point. -9.25. In the year 2003, what is the difference between the Female students (as % of total students) in Fragile and conflict affected situations and Female students (as % of total students) in Senegal?
Your response must be concise. 2.22. In the year 2003, what is the difference between the Female students (as % of total students) in Austria and Female students (as % of total students) in Cuba?
Offer a terse response. -2.26. In the year 2003, what is the difference between the Female students (as % of total students) in Austria and Female students (as % of total students) in Senegal?
Offer a very short reply. 9.21. In the year 2003, what is the difference between the Female students (as % of total students) of Cuba and Female students (as % of total students) of Senegal?
Your answer should be very brief. 11.47. In the year 2004, what is the difference between the Female students (as % of total students) in Fragile and conflict affected situations and Female students (as % of total students) in Austria?
Provide a short and direct response. -7.51. In the year 2004, what is the difference between the Female students (as % of total students) in Fragile and conflict affected situations and Female students (as % of total students) in Cuba?
Provide a succinct answer. -9.25. In the year 2004, what is the difference between the Female students (as % of total students) of Fragile and conflict affected situations and Female students (as % of total students) of Senegal?
Your answer should be compact. 0.67. In the year 2004, what is the difference between the Female students (as % of total students) of Austria and Female students (as % of total students) of Cuba?
Ensure brevity in your answer.  -1.74. In the year 2004, what is the difference between the Female students (as % of total students) in Austria and Female students (as % of total students) in Senegal?
Your answer should be compact. 8.18. In the year 2004, what is the difference between the Female students (as % of total students) of Cuba and Female students (as % of total students) of Senegal?
Your answer should be very brief. 9.93. In the year 2005, what is the difference between the Female students (as % of total students) of Fragile and conflict affected situations and Female students (as % of total students) of Austria?
Offer a very short reply. -6.97. In the year 2005, what is the difference between the Female students (as % of total students) of Fragile and conflict affected situations and Female students (as % of total students) of Cuba?
Your response must be concise. -8.22. In the year 2005, what is the difference between the Female students (as % of total students) of Fragile and conflict affected situations and Female students (as % of total students) of Senegal?
Offer a terse response. 0.43. In the year 2005, what is the difference between the Female students (as % of total students) of Austria and Female students (as % of total students) of Cuba?
Ensure brevity in your answer.  -1.25. In the year 2005, what is the difference between the Female students (as % of total students) in Austria and Female students (as % of total students) in Senegal?
Offer a very short reply. 7.4. In the year 2005, what is the difference between the Female students (as % of total students) of Cuba and Female students (as % of total students) of Senegal?
Provide a short and direct response. 8.66. In the year 2006, what is the difference between the Female students (as % of total students) in Fragile and conflict affected situations and Female students (as % of total students) in Austria?
Provide a short and direct response. -7.03. In the year 2006, what is the difference between the Female students (as % of total students) in Fragile and conflict affected situations and Female students (as % of total students) in Cuba?
Give a very brief answer. -8.17. In the year 2006, what is the difference between the Female students (as % of total students) of Fragile and conflict affected situations and Female students (as % of total students) of Senegal?
Your answer should be compact. 0.06. In the year 2006, what is the difference between the Female students (as % of total students) in Austria and Female students (as % of total students) in Cuba?
Provide a short and direct response. -1.14. In the year 2006, what is the difference between the Female students (as % of total students) in Austria and Female students (as % of total students) in Senegal?
Give a very brief answer. 7.09. In the year 2006, what is the difference between the Female students (as % of total students) of Cuba and Female students (as % of total students) of Senegal?
Provide a short and direct response. 8.23. In the year 2007, what is the difference between the Female students (as % of total students) in Fragile and conflict affected situations and Female students (as % of total students) in Austria?
Provide a short and direct response. -6.91. In the year 2007, what is the difference between the Female students (as % of total students) of Fragile and conflict affected situations and Female students (as % of total students) of Cuba?
Offer a terse response. -8.02. In the year 2007, what is the difference between the Female students (as % of total students) in Austria and Female students (as % of total students) in Cuba?
Offer a terse response. -1.11. In the year 2007, what is the difference between the Female students (as % of total students) of Austria and Female students (as % of total students) of Senegal?
Offer a very short reply. 7.02. In the year 2007, what is the difference between the Female students (as % of total students) of Cuba and Female students (as % of total students) of Senegal?
Make the answer very short. 8.13. In the year 2008, what is the difference between the Female students (as % of total students) in Fragile and conflict affected situations and Female students (as % of total students) in Austria?
Offer a very short reply. -6.93. In the year 2008, what is the difference between the Female students (as % of total students) of Fragile and conflict affected situations and Female students (as % of total students) of Cuba?
Make the answer very short. -8.04. In the year 2008, what is the difference between the Female students (as % of total students) of Fragile and conflict affected situations and Female students (as % of total students) of Senegal?
Offer a terse response. -0.58. In the year 2008, what is the difference between the Female students (as % of total students) of Austria and Female students (as % of total students) of Cuba?
Make the answer very short. -1.11. In the year 2008, what is the difference between the Female students (as % of total students) in Austria and Female students (as % of total students) in Senegal?
Provide a short and direct response. 6.35. In the year 2008, what is the difference between the Female students (as % of total students) of Cuba and Female students (as % of total students) of Senegal?
Your answer should be very brief. 7.46. What is the ratio of the Female students (as % of total students) in Fragile and conflict affected situations in 2001 to that in 2002?
Offer a very short reply. 0.98. What is the ratio of the Female students (as % of total students) of Cuba in 2001 to that in 2002?
Offer a terse response. 1. What is the ratio of the Female students (as % of total students) of Fragile and conflict affected situations in 2001 to that in 2003?
Your answer should be compact. 0.97. What is the ratio of the Female students (as % of total students) of Austria in 2001 to that in 2003?
Keep it short and to the point. 1. What is the ratio of the Female students (as % of total students) of Cuba in 2001 to that in 2003?
Provide a short and direct response. 1.02. What is the ratio of the Female students (as % of total students) in Senegal in 2001 to that in 2003?
Your response must be concise. 0.98. What is the ratio of the Female students (as % of total students) in Fragile and conflict affected situations in 2001 to that in 2004?
Your answer should be very brief. 0.98. What is the ratio of the Female students (as % of total students) in Cuba in 2001 to that in 2004?
Keep it short and to the point. 1.03. What is the ratio of the Female students (as % of total students) in Senegal in 2001 to that in 2004?
Provide a succinct answer. 0.95. What is the ratio of the Female students (as % of total students) of Fragile and conflict affected situations in 2001 to that in 2005?
Ensure brevity in your answer.  0.97. What is the ratio of the Female students (as % of total students) of Austria in 2001 to that in 2005?
Offer a very short reply. 1. What is the ratio of the Female students (as % of total students) of Cuba in 2001 to that in 2005?
Your answer should be compact. 1.04. What is the ratio of the Female students (as % of total students) in Senegal in 2001 to that in 2005?
Offer a terse response. 0.93. What is the ratio of the Female students (as % of total students) of Senegal in 2001 to that in 2006?
Your answer should be compact. 0.92. What is the ratio of the Female students (as % of total students) of Austria in 2001 to that in 2007?
Your answer should be compact. 0.99. What is the ratio of the Female students (as % of total students) in Cuba in 2001 to that in 2007?
Provide a short and direct response. 1.04. What is the ratio of the Female students (as % of total students) of Senegal in 2001 to that in 2007?
Offer a terse response. 0.92. What is the ratio of the Female students (as % of total students) of Fragile and conflict affected situations in 2001 to that in 2008?
Ensure brevity in your answer.  0.96. What is the ratio of the Female students (as % of total students) of Cuba in 2001 to that in 2008?
Provide a short and direct response. 1.03. What is the ratio of the Female students (as % of total students) in Senegal in 2001 to that in 2008?
Ensure brevity in your answer.  0.9. What is the ratio of the Female students (as % of total students) of Fragile and conflict affected situations in 2002 to that in 2003?
Keep it short and to the point. 0.99. What is the ratio of the Female students (as % of total students) in Cuba in 2002 to that in 2003?
Keep it short and to the point. 1.02. What is the ratio of the Female students (as % of total students) of Senegal in 2002 to that in 2003?
Your response must be concise. 0.98. What is the ratio of the Female students (as % of total students) in Cuba in 2002 to that in 2004?
Make the answer very short. 1.02. What is the ratio of the Female students (as % of total students) of Senegal in 2002 to that in 2004?
Ensure brevity in your answer.  0.96. What is the ratio of the Female students (as % of total students) in Fragile and conflict affected situations in 2002 to that in 2005?
Provide a short and direct response. 0.98. What is the ratio of the Female students (as % of total students) in Cuba in 2002 to that in 2005?
Your answer should be compact. 1.03. What is the ratio of the Female students (as % of total students) of Senegal in 2002 to that in 2005?
Your response must be concise. 0.94. What is the ratio of the Female students (as % of total students) in Fragile and conflict affected situations in 2002 to that in 2006?
Make the answer very short. 0.98. What is the ratio of the Female students (as % of total students) in Austria in 2002 to that in 2006?
Your response must be concise. 1. What is the ratio of the Female students (as % of total students) in Cuba in 2002 to that in 2006?
Offer a very short reply. 1.03. What is the ratio of the Female students (as % of total students) in Senegal in 2002 to that in 2006?
Offer a very short reply. 0.93. What is the ratio of the Female students (as % of total students) of Fragile and conflict affected situations in 2002 to that in 2007?
Provide a succinct answer. 0.98. What is the ratio of the Female students (as % of total students) in Cuba in 2002 to that in 2007?
Ensure brevity in your answer.  1.03. What is the ratio of the Female students (as % of total students) of Senegal in 2002 to that in 2007?
Your response must be concise. 0.93. What is the ratio of the Female students (as % of total students) of Fragile and conflict affected situations in 2002 to that in 2008?
Your answer should be compact. 0.98. What is the ratio of the Female students (as % of total students) of Cuba in 2002 to that in 2008?
Your answer should be compact. 1.03. What is the ratio of the Female students (as % of total students) of Senegal in 2002 to that in 2008?
Your response must be concise. 0.91. What is the ratio of the Female students (as % of total students) in Fragile and conflict affected situations in 2003 to that in 2004?
Keep it short and to the point. 1.01. What is the ratio of the Female students (as % of total students) in Cuba in 2003 to that in 2004?
Your response must be concise. 1.01. What is the ratio of the Female students (as % of total students) of Senegal in 2003 to that in 2004?
Offer a terse response. 0.97. What is the ratio of the Female students (as % of total students) of Austria in 2003 to that in 2005?
Provide a short and direct response. 1. What is the ratio of the Female students (as % of total students) of Cuba in 2003 to that in 2005?
Your answer should be compact. 1.02. What is the ratio of the Female students (as % of total students) of Senegal in 2003 to that in 2005?
Your response must be concise. 0.95. What is the ratio of the Female students (as % of total students) in Austria in 2003 to that in 2006?
Your answer should be very brief. 1. What is the ratio of the Female students (as % of total students) in Cuba in 2003 to that in 2006?
Your response must be concise. 1.02. What is the ratio of the Female students (as % of total students) of Senegal in 2003 to that in 2006?
Your response must be concise. 0.95. What is the ratio of the Female students (as % of total students) of Fragile and conflict affected situations in 2003 to that in 2007?
Your answer should be compact. 0.99. What is the ratio of the Female students (as % of total students) in Cuba in 2003 to that in 2007?
Offer a terse response. 1.02. What is the ratio of the Female students (as % of total students) in Senegal in 2003 to that in 2007?
Your answer should be compact. 0.94. What is the ratio of the Female students (as % of total students) of Fragile and conflict affected situations in 2003 to that in 2008?
Your response must be concise. 0.99. What is the ratio of the Female students (as % of total students) of Cuba in 2003 to that in 2008?
Give a very brief answer. 1.01. What is the ratio of the Female students (as % of total students) in Senegal in 2003 to that in 2008?
Provide a short and direct response. 0.93. What is the ratio of the Female students (as % of total students) in Fragile and conflict affected situations in 2004 to that in 2005?
Your answer should be compact. 0.99. What is the ratio of the Female students (as % of total students) in Cuba in 2004 to that in 2005?
Make the answer very short. 1.01. What is the ratio of the Female students (as % of total students) in Senegal in 2004 to that in 2005?
Your answer should be very brief. 0.98. What is the ratio of the Female students (as % of total students) of Fragile and conflict affected situations in 2004 to that in 2006?
Keep it short and to the point. 0.99. What is the ratio of the Female students (as % of total students) in Austria in 2004 to that in 2006?
Provide a short and direct response. 1. What is the ratio of the Female students (as % of total students) of Cuba in 2004 to that in 2006?
Offer a terse response. 1.01. What is the ratio of the Female students (as % of total students) of Senegal in 2004 to that in 2006?
Your response must be concise. 0.97. What is the ratio of the Female students (as % of total students) in Fragile and conflict affected situations in 2004 to that in 2007?
Ensure brevity in your answer.  0.98. What is the ratio of the Female students (as % of total students) of Cuba in 2004 to that in 2007?
Make the answer very short. 1.01. What is the ratio of the Female students (as % of total students) of Senegal in 2004 to that in 2007?
Offer a very short reply. 0.97. What is the ratio of the Female students (as % of total students) in Fragile and conflict affected situations in 2004 to that in 2008?
Offer a very short reply. 0.98. What is the ratio of the Female students (as % of total students) in Cuba in 2004 to that in 2008?
Ensure brevity in your answer.  1.01. What is the ratio of the Female students (as % of total students) of Senegal in 2004 to that in 2008?
Keep it short and to the point. 0.95. What is the ratio of the Female students (as % of total students) in Austria in 2005 to that in 2006?
Keep it short and to the point. 1. What is the ratio of the Female students (as % of total students) in Cuba in 2005 to that in 2006?
Give a very brief answer. 1. What is the ratio of the Female students (as % of total students) of Fragile and conflict affected situations in 2005 to that in 2007?
Give a very brief answer. 0.99. What is the ratio of the Female students (as % of total students) in Austria in 2005 to that in 2007?
Provide a short and direct response. 1. What is the ratio of the Female students (as % of total students) in Senegal in 2005 to that in 2007?
Your answer should be compact. 0.99. What is the ratio of the Female students (as % of total students) in Fragile and conflict affected situations in 2005 to that in 2008?
Ensure brevity in your answer.  0.99. What is the ratio of the Female students (as % of total students) in Cuba in 2005 to that in 2008?
Offer a terse response. 1. What is the ratio of the Female students (as % of total students) in Senegal in 2005 to that in 2008?
Provide a short and direct response. 0.97. What is the ratio of the Female students (as % of total students) in Austria in 2006 to that in 2007?
Ensure brevity in your answer.  1. What is the ratio of the Female students (as % of total students) in Cuba in 2006 to that in 2007?
Provide a succinct answer. 1. What is the ratio of the Female students (as % of total students) in Austria in 2006 to that in 2008?
Provide a short and direct response. 1. What is the ratio of the Female students (as % of total students) in Cuba in 2006 to that in 2008?
Provide a succinct answer. 1. What is the ratio of the Female students (as % of total students) in Senegal in 2006 to that in 2008?
Ensure brevity in your answer.  0.98. What is the ratio of the Female students (as % of total students) in Austria in 2007 to that in 2008?
Your answer should be very brief. 1. What is the ratio of the Female students (as % of total students) of Cuba in 2007 to that in 2008?
Your answer should be very brief. 1. What is the ratio of the Female students (as % of total students) in Senegal in 2007 to that in 2008?
Keep it short and to the point. 0.98. What is the difference between the highest and the second highest Female students (as % of total students) of Fragile and conflict affected situations?
Your response must be concise. 0.07. What is the difference between the highest and the second highest Female students (as % of total students) in Austria?
Your answer should be very brief. 0.08. What is the difference between the highest and the second highest Female students (as % of total students) in Cuba?
Your answer should be very brief. 0.23. What is the difference between the highest and the second highest Female students (as % of total students) in Senegal?
Provide a short and direct response. 0.76. What is the difference between the highest and the lowest Female students (as % of total students) in Fragile and conflict affected situations?
Provide a succinct answer. 1.75. What is the difference between the highest and the lowest Female students (as % of total students) in Austria?
Keep it short and to the point. 0.4. What is the difference between the highest and the lowest Female students (as % of total students) of Cuba?
Provide a succinct answer. 1.97. What is the difference between the highest and the lowest Female students (as % of total students) in Senegal?
Ensure brevity in your answer.  4.24. 